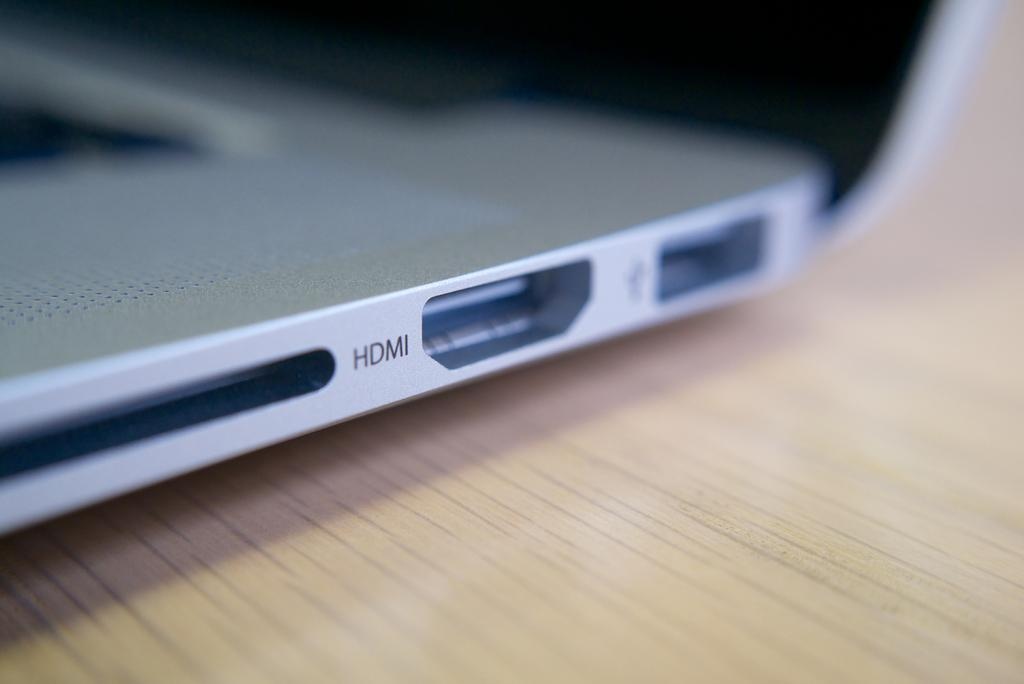<image>
Describe the image concisely. The laptop can support HDMI, USB, and CDs. 